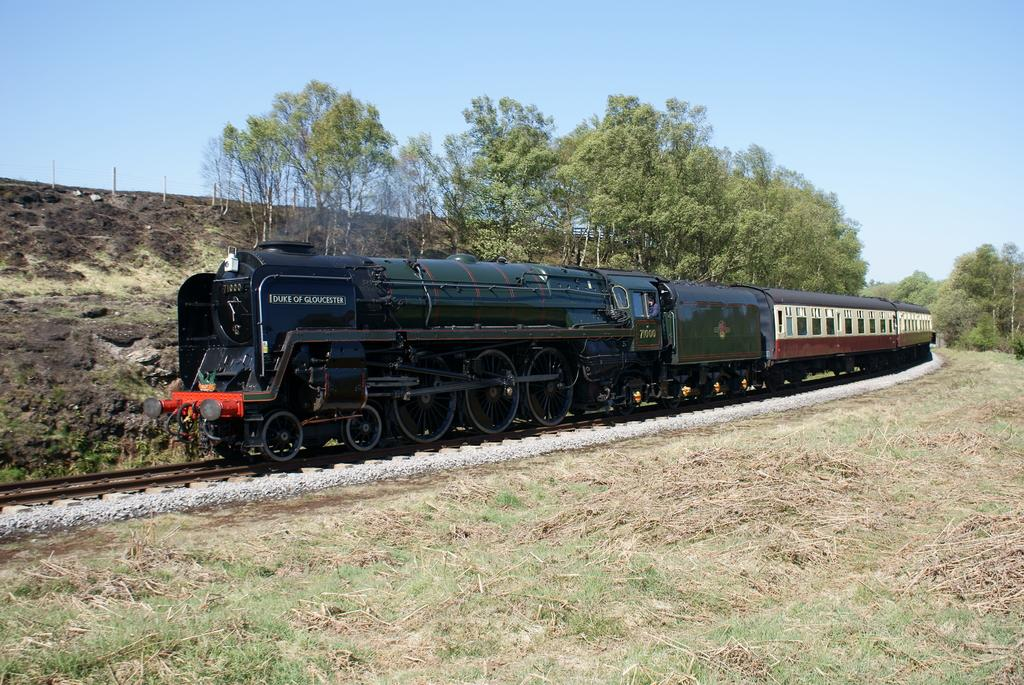What is the main subject of the image? The main subject of the image is a train. Where is the train located in the image? The train is on a railway track. What can be seen in the background of the image? There are trees and the sky visible in the background of the image. How many cards are being held by the train in the image? There are no cards present in the image, as it features a train on a railway track. How many beds are visible in the image? There are no beds visible in the image, as it features a train on a railway track. 